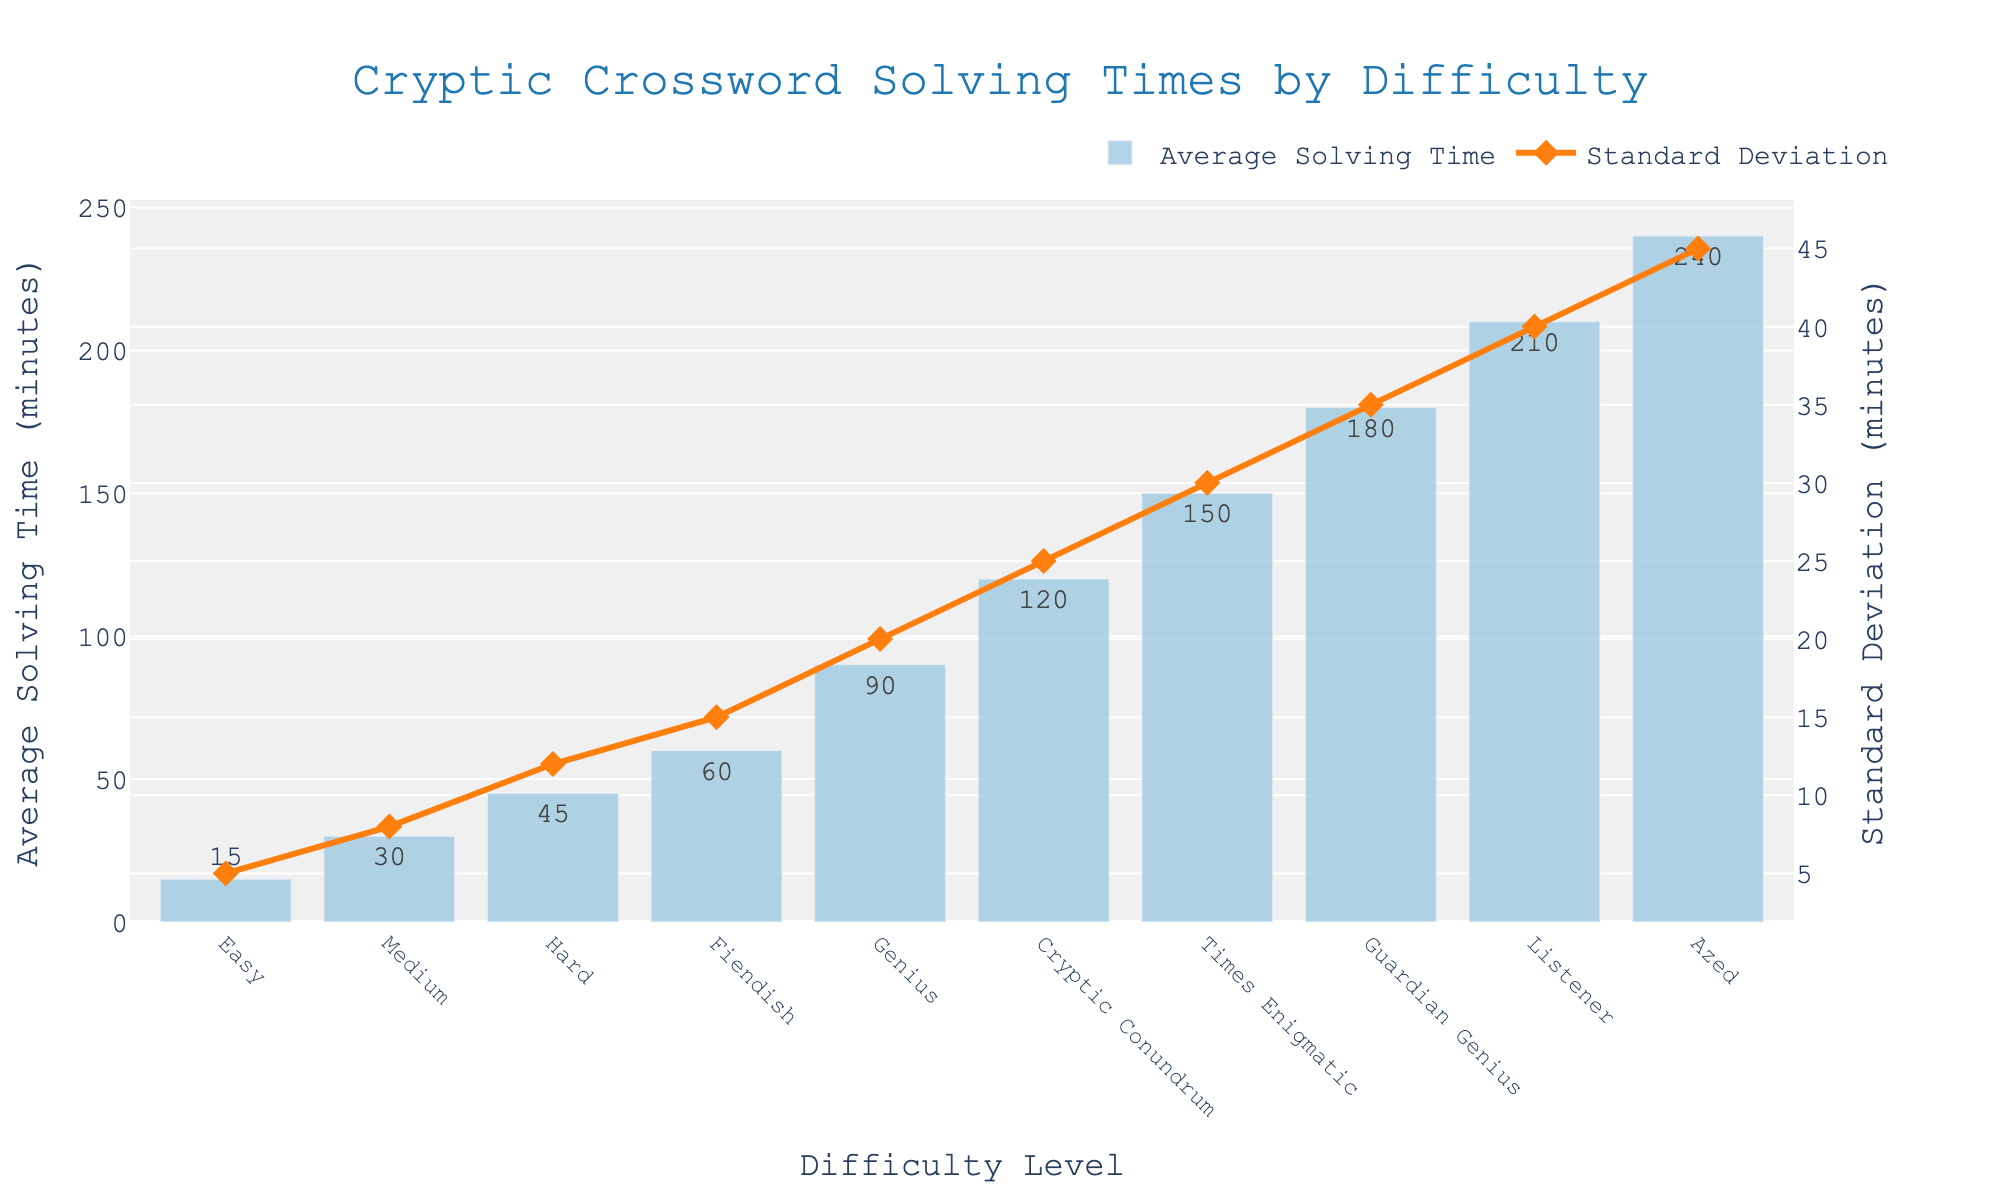What is the average solving time for "Genius" and how is it visually represented? The "Genius" category has an average solving time of 90 minutes. This is represented by the height of the bar for "Genius", labeled with the value 90.
Answer: 90 minutes Which difficulty level has the highest standard deviation, and how do you identify it in the chart? The highest standard deviation is for the "Azed" difficulty level, marked by the highest point on the line plot with the y-axis labeled as 45 minutes.
Answer: Azed Compare the average solving times between "Medium" and "Fiendish" difficulties. Which one is higher and by how much? "Fiendish" has an average solving time of 60 minutes, while "Medium" has an average of 30 minutes. The difference is 60 - 30 = 30 minutes.
Answer: Fiendish by 30 minutes What is the sum of the average solving times for "Easy" and "Hard" difficulty levels? The average solving time for "Easy" is 15 minutes and for "Hard" is 45 minutes. Their sum is 15 + 45 = 60 minutes.
Answer: 60 minutes Identify the difficulty level where the average solving time surpasses 200 minutes and provide its standard deviation. Both "Listener" and "Azed" surpass 200 minutes with average solving times of 210 and 240 minutes, respectively. "Listener" has a standard deviation of 40 minutes, and "Azed" has 45 minutes.
Answer: Listener: 40 minutes, Azed: 45 minutes How does the solving time standard deviation trend as the difficulty level increases? As the difficulty level increases from "Easy" to "Azed", the standard deviation also rises steadily from 5 minutes to 45 minutes, indicated by the ascending line plot.
Answer: Increases Which difficulty level has an average solving time located halfway between "Hard" and "Times Enigmatic"? "Hard" has an average solving time of 45 minutes, and "Times Enigmatic" has 150 minutes. Halfway is (45 + 150) / 2 = 97.5 minutes, closest to "Genius" with 90 minutes.
Answer: Genius 